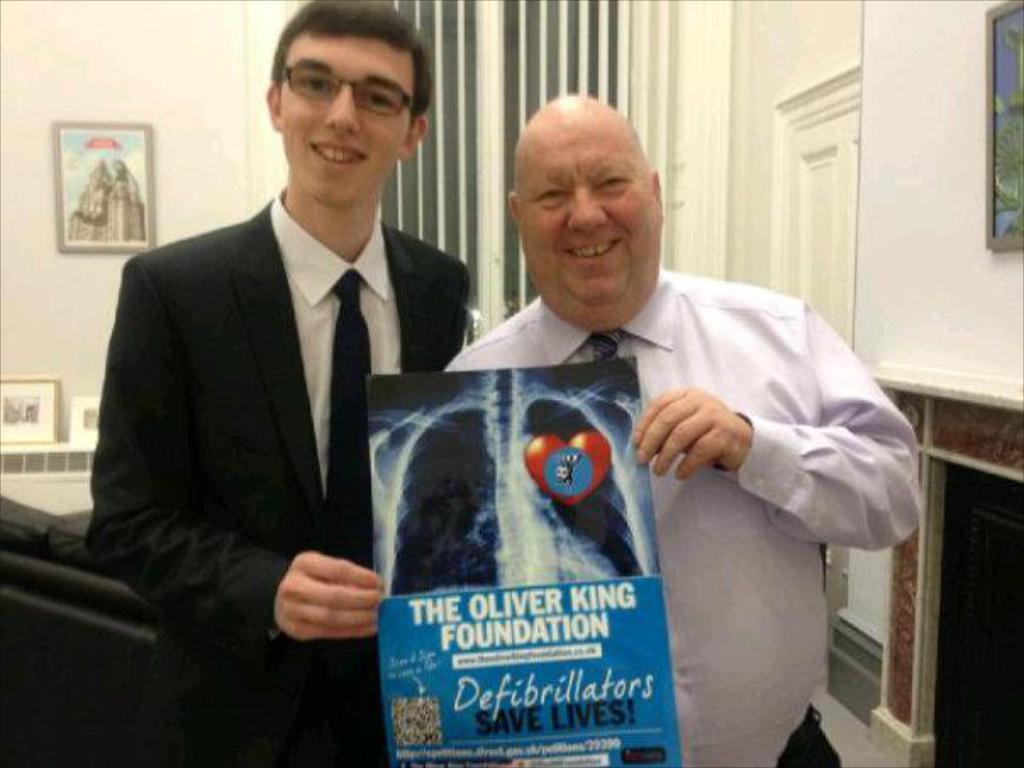In one or two sentences, can you explain what this image depicts? In the image we can see there are men standing and they are holding an x-ray sheet in their hand. Behind there is a photo frame on the wall. 